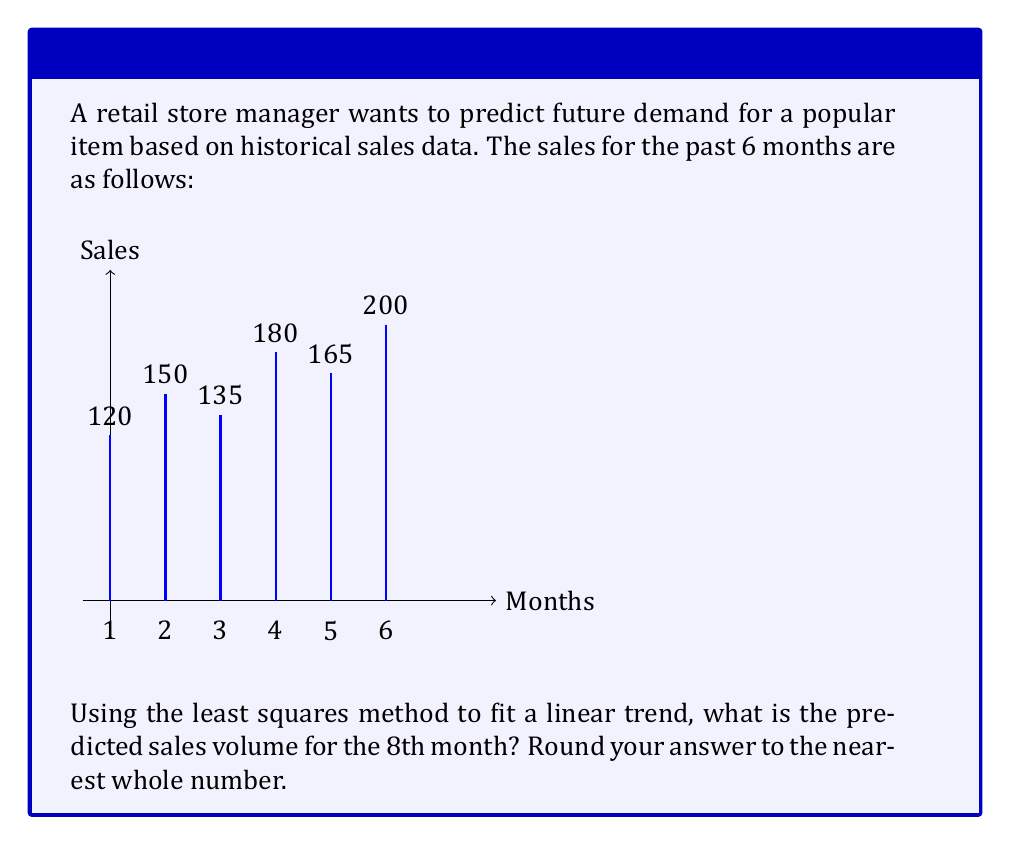What is the answer to this math problem? To predict future demand using the least squares method:

1) Let $x$ represent the month number and $y$ represent the sales.

2) We need to calculate:
   $\bar{x} = \frac{\sum x}{n}$, $\bar{y} = \frac{\sum y}{n}$
   $S_{xx} = \sum(x - \bar{x})^2$, $S_{xy} = \sum(x - \bar{x})(y - \bar{y})$

3) Calculate the slope $b$ and y-intercept $a$:
   $b = \frac{S_{xy}}{S_{xx}}$, $a = \bar{y} - b\bar{x}$

4) Our data:
   $x: 1, 2, 3, 4, 5, 6$
   $y: 120, 150, 135, 180, 165, 200$

5) Calculations:
   $\bar{x} = \frac{1+2+3+4+5+6}{6} = 3.5$
   $\bar{y} = \frac{120+150+135+180+165+200}{6} = 158.33$

   $S_{xx} = (1-3.5)^2 + (2-3.5)^2 + ... + (6-3.5)^2 = 17.5$
   $S_{xy} = (1-3.5)(120-158.33) + ... + (6-3.5)(200-158.33) = 262.5$

6) Slope and y-intercept:
   $b = \frac{262.5}{17.5} = 15$
   $a = 158.33 - 15(3.5) = 106.08$

7) Linear equation: $y = 15x + 106.08$

8) For the 8th month, $x = 8$:
   $y = 15(8) + 106.08 = 226.08$

9) Rounding to the nearest whole number: 226
Answer: 226 